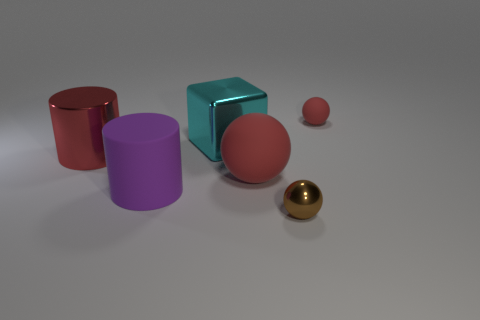Add 2 cyan shiny balls. How many objects exist? 8 Subtract all cylinders. How many objects are left? 4 Add 4 red objects. How many red objects are left? 7 Add 4 big purple things. How many big purple things exist? 5 Subtract 0 yellow cylinders. How many objects are left? 6 Subtract all tiny brown blocks. Subtract all large matte cylinders. How many objects are left? 5 